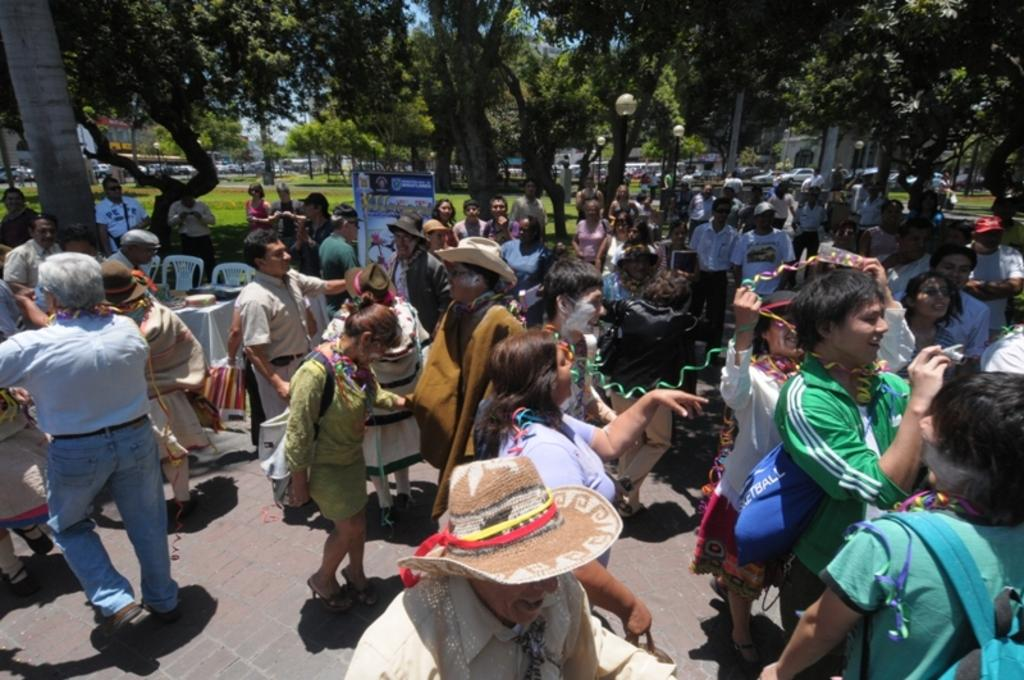What is the main subject of the image? There is a group of people on the ground. What objects are present in the image that might be used for sitting? There are chairs in the image. What type of signage is visible in the image? There is a poster in the image. What items can be seen that might be used for carrying belongings? There are bags in the image. What type of transportation is visible in the image? There are vehicles in the image. What type of structures are present in the image that provide illumination? There are light poles in the image. What type of natural vegetation is visible in the image? There is grass and trees in the image. What other objects can be seen in the image? There are some objects in the image. What is visible in the background of the image? The sky is visible in the background of the image. What type of nail can be seen in the image? There is no nail present in the image. What is the group of people's desire in the image? There is no indication of the group's desires in the image. 